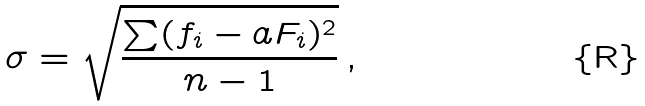Convert formula to latex. <formula><loc_0><loc_0><loc_500><loc_500>\sigma = \sqrt { \frac { \sum ( f _ { i } - a F _ { i } ) ^ { 2 } } { n - 1 } } \, ,</formula> 